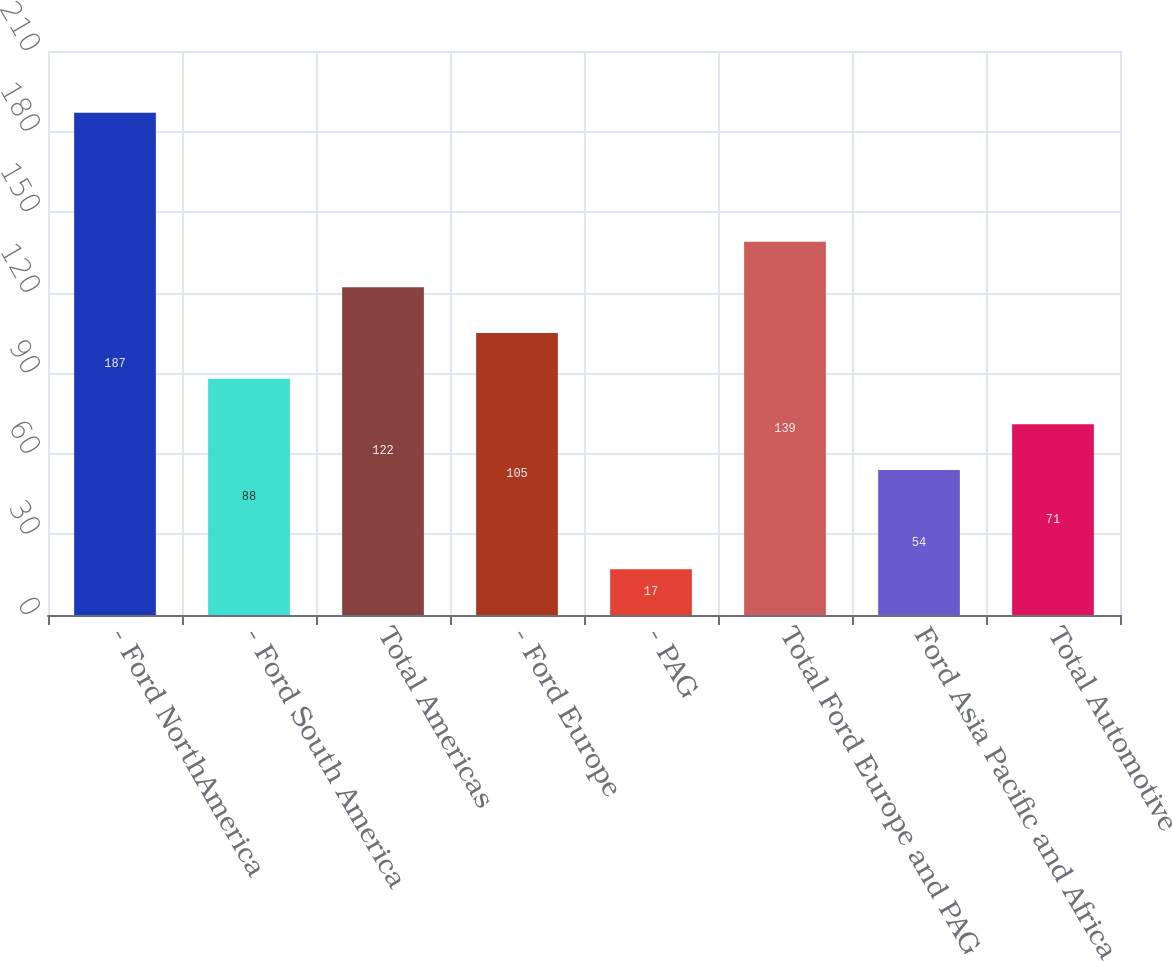<chart> <loc_0><loc_0><loc_500><loc_500><bar_chart><fcel>- Ford NorthAmerica<fcel>- Ford South America<fcel>Total Americas<fcel>- Ford Europe<fcel>- PAG<fcel>Total Ford Europe and PAG<fcel>Ford Asia Pacific and Africa<fcel>Total Automotive<nl><fcel>187<fcel>88<fcel>122<fcel>105<fcel>17<fcel>139<fcel>54<fcel>71<nl></chart> 